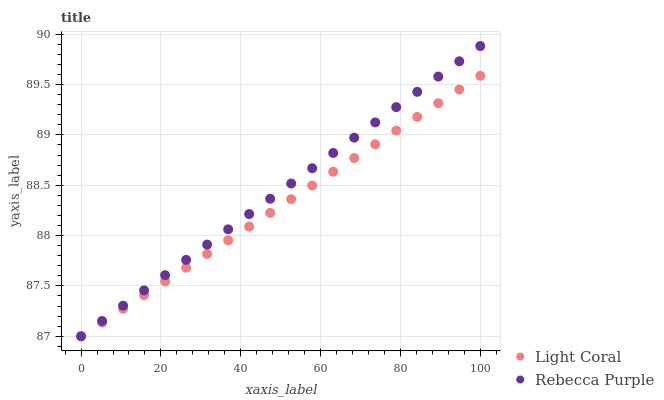Does Light Coral have the minimum area under the curve?
Answer yes or no. Yes. Does Rebecca Purple have the maximum area under the curve?
Answer yes or no. Yes. Does Rebecca Purple have the minimum area under the curve?
Answer yes or no. No. Is Rebecca Purple the smoothest?
Answer yes or no. Yes. Is Light Coral the roughest?
Answer yes or no. Yes. Is Rebecca Purple the roughest?
Answer yes or no. No. Does Light Coral have the lowest value?
Answer yes or no. Yes. Does Rebecca Purple have the highest value?
Answer yes or no. Yes. Does Rebecca Purple intersect Light Coral?
Answer yes or no. Yes. Is Rebecca Purple less than Light Coral?
Answer yes or no. No. Is Rebecca Purple greater than Light Coral?
Answer yes or no. No. 